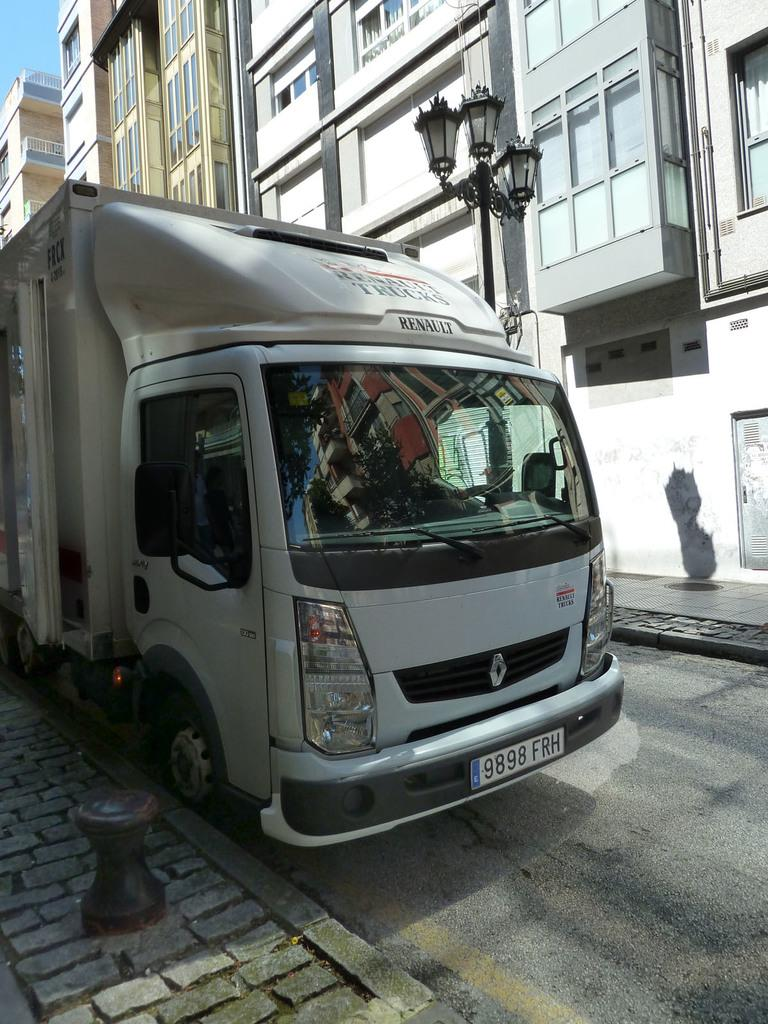What is the main subject in the center of the image? There is a vehicle in the center of the image. What can be seen in the background of the image? There are buildings, a pole, and a street light in the background of the image. What type of surface is visible in the image? There is a pavement in the image. What is at the bottom of the image? There is a road and an object at the bottom of the image. What type of beef is being cooked on the pavement in the image? There is no beef or any cooking activity present in the image. 